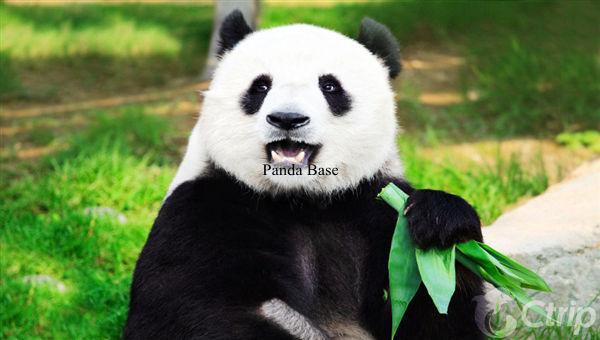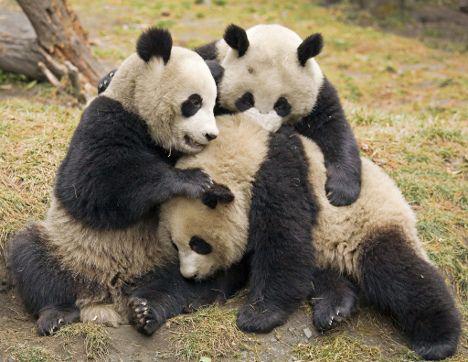The first image is the image on the left, the second image is the image on the right. Analyze the images presented: Is the assertion "One image shows multiple pandas sitting in a group chewing on stalks, and the other includes a panda with its arms flung wide." valid? Answer yes or no. No. The first image is the image on the left, the second image is the image on the right. Examine the images to the left and right. Is the description "There are at most 5 pandas in the image pair." accurate? Answer yes or no. Yes. 